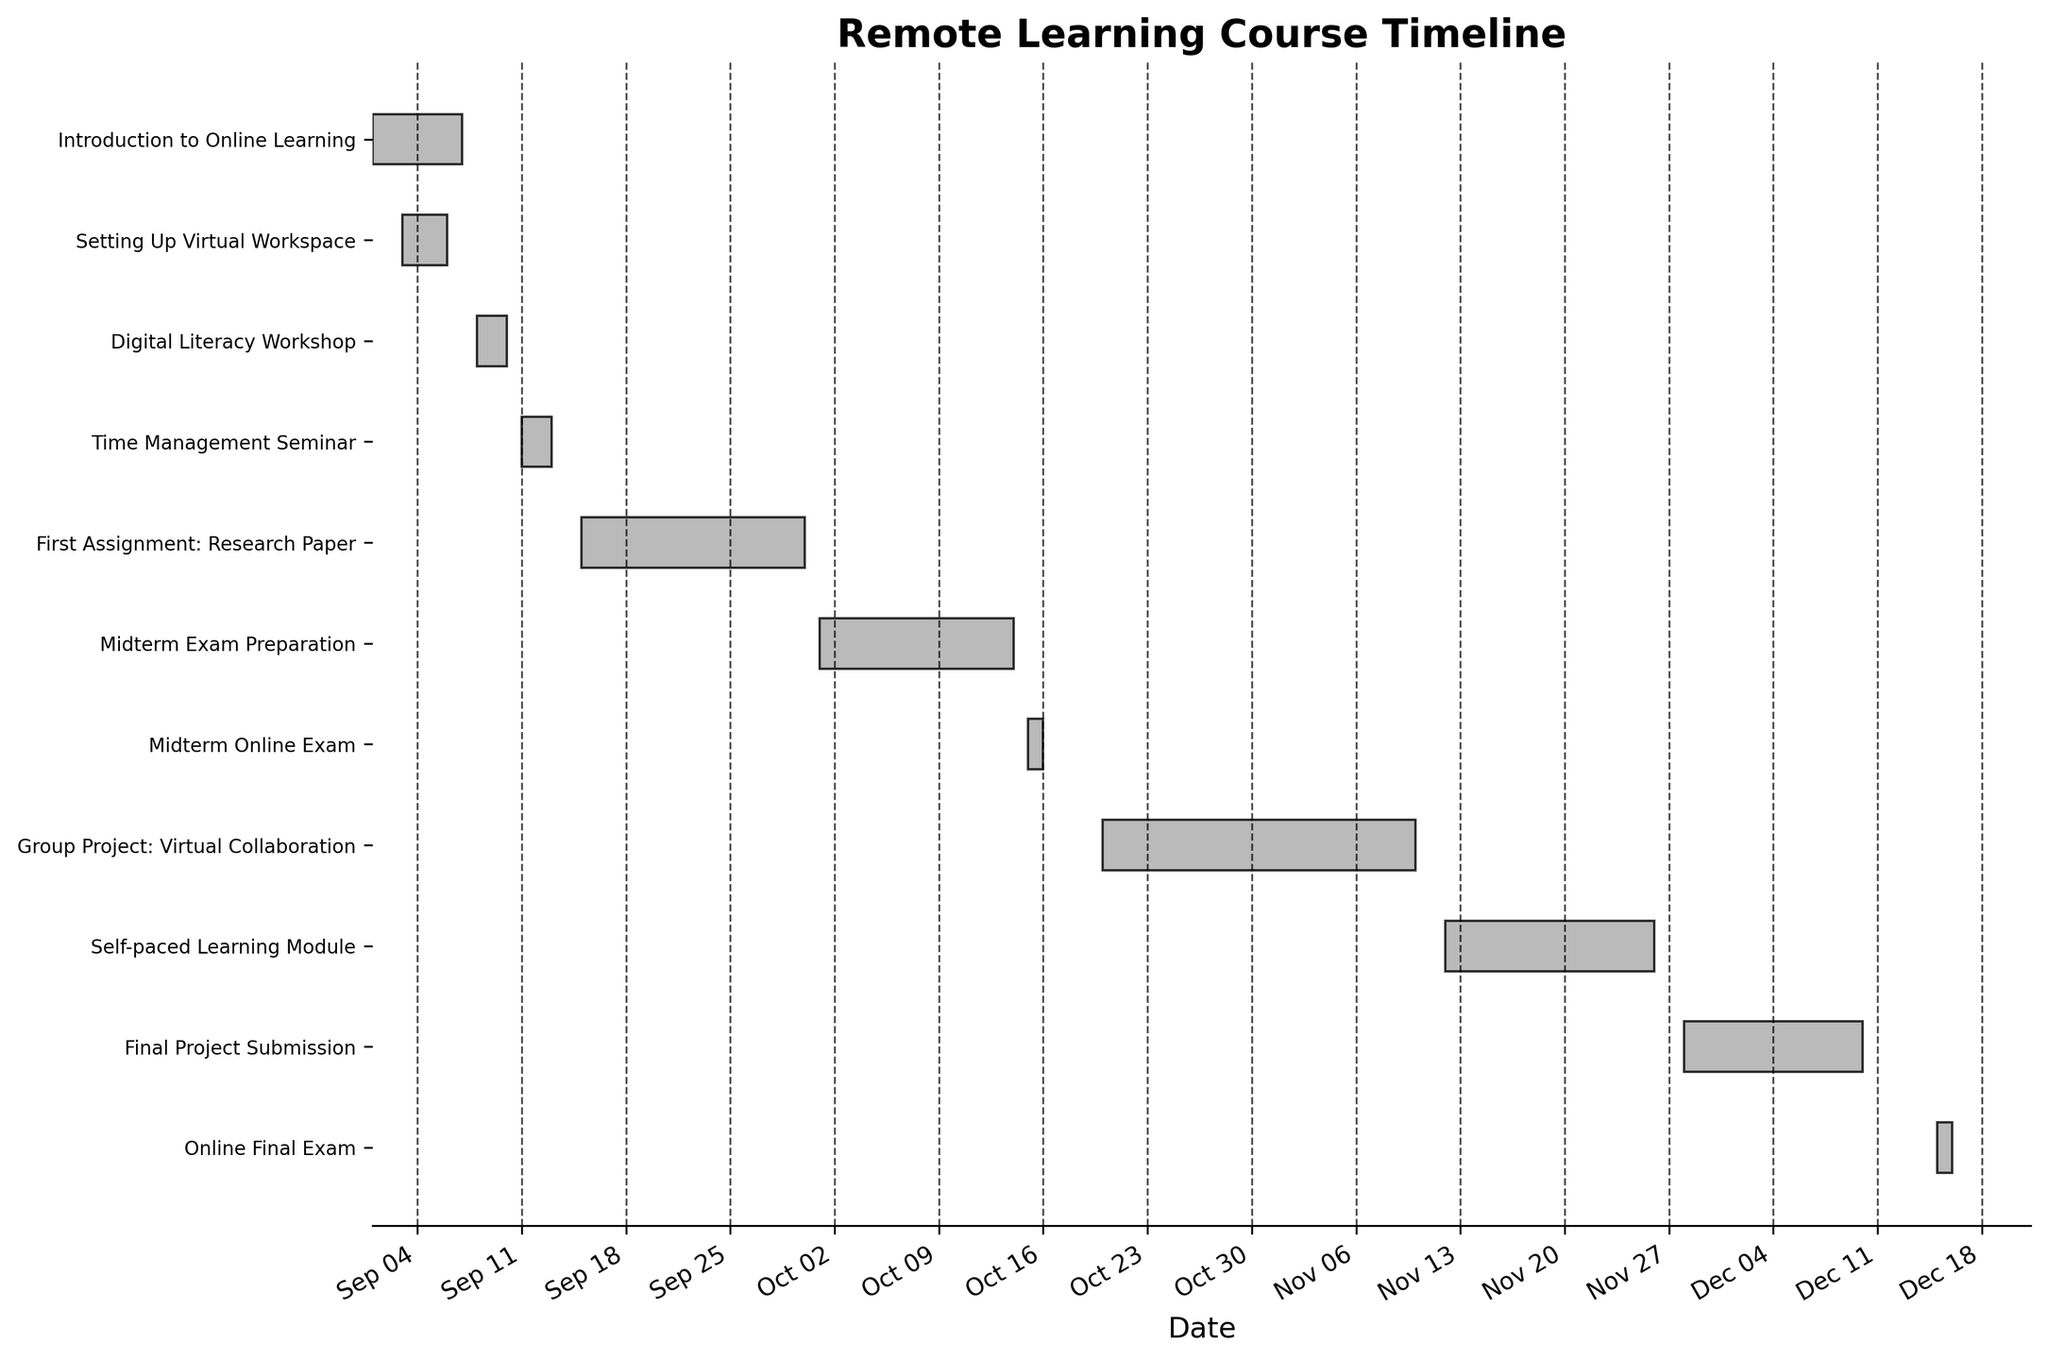What is the title of the Gantt chart? At the top of the Gantt chart, there is a title that describes what the chart represents.
Answer: Remote Learning Course Timeline Which task starts first? By looking at the start dates on the x-axis, we can see that the earliest date is 2023-09-01, which corresponds to "Introduction to Online Learning."
Answer: Introduction to Online Learning How long does the "Midterm Exam Preparation" task last? The start date for "Midterm Exam Preparation" is 2023-10-01, and the end date is 2023-10-14. The number of days between these dates is 14 – 1 + 1 = 14 days.
Answer: 14 days Are there any tasks that overlap with the "Setting Up Virtual Workspace" task? "Setting Up Virtual Workspace" runs from 2023-09-03 to 2023-09-06. By checking other tasks with their dates, we see that "Introduction to Online Learning" (2023-09-01 to 2023-09-07) overlaps.
Answer: Yes, "Introduction to Online Learning" Which task has the shortest duration? By comparing the lengths of the bars representing the tasks, "Midterm Online Exam" and "Online Final Exam" both span only 2 days each.
Answer: Midterm Online Exam and Online Final Exam How many tasks are there in total? By counting the total number of horizontal bars, we can see there are 11 tasks.
Answer: 11 Which task ends last? By looking at the end dates on the x-axis and checking the farthest right bar, we see that "Online Final Exam" ends on 2023-12-16.
Answer: Online Final Exam What is the duration of the "Group Project: Virtual Collaboration"? The start date is 2023-10-20 and the end date is 2023-11-10. The duration is calculated as 11-10 + 1 = 22 days.
Answer: 22 days How many tasks are there in October? Tasks that fall at least partially in October are: "Midterm Exam Preparation," "Midterm Online Exam," and "Group Project: Virtual Collaboration." Counting these, we find there are 3 tasks.
Answer: 3 tasks Is there any gap between "Self-paced Learning Module" and "Final Project Submission"? "Self-paced Learning Module" ends on 2023-11-26, and "Final Project Submission" starts on 2023-11-28. There is a 1-day gap in between.
Answer: Yes, 1 day gap 